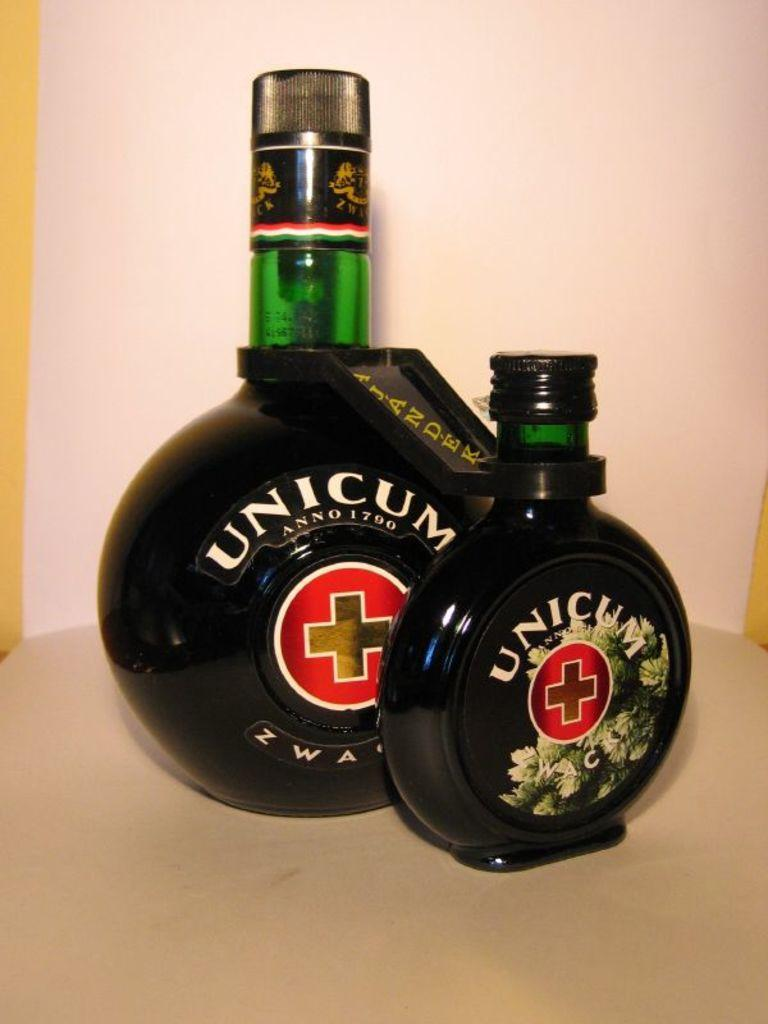<image>
Create a compact narrative representing the image presented. Two bottles of Unicum sit against a white bacground 